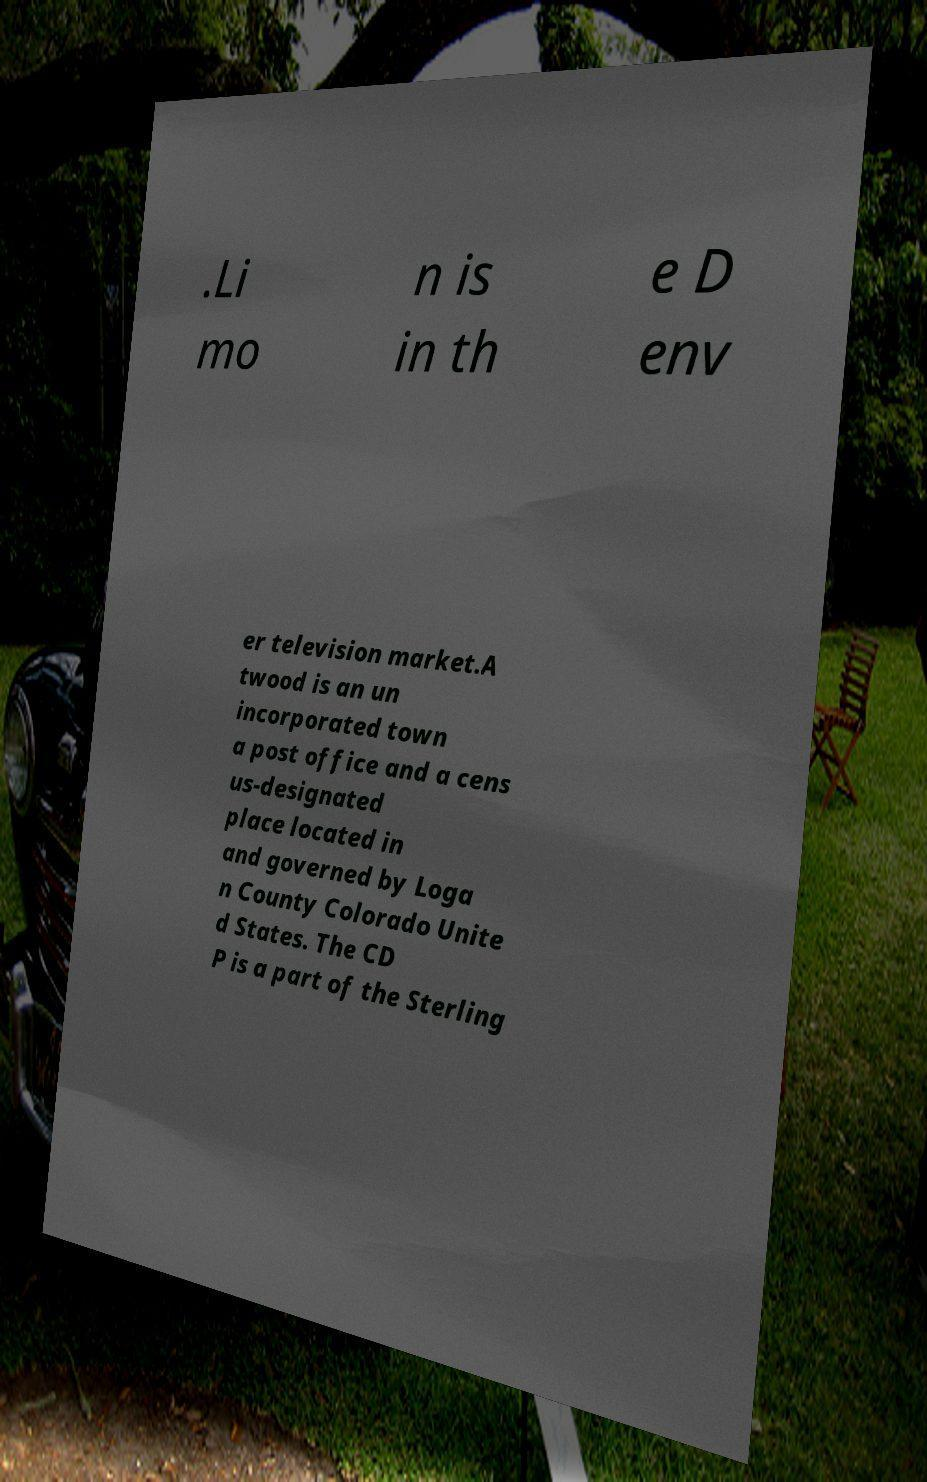Could you assist in decoding the text presented in this image and type it out clearly? .Li mo n is in th e D env er television market.A twood is an un incorporated town a post office and a cens us-designated place located in and governed by Loga n County Colorado Unite d States. The CD P is a part of the Sterling 